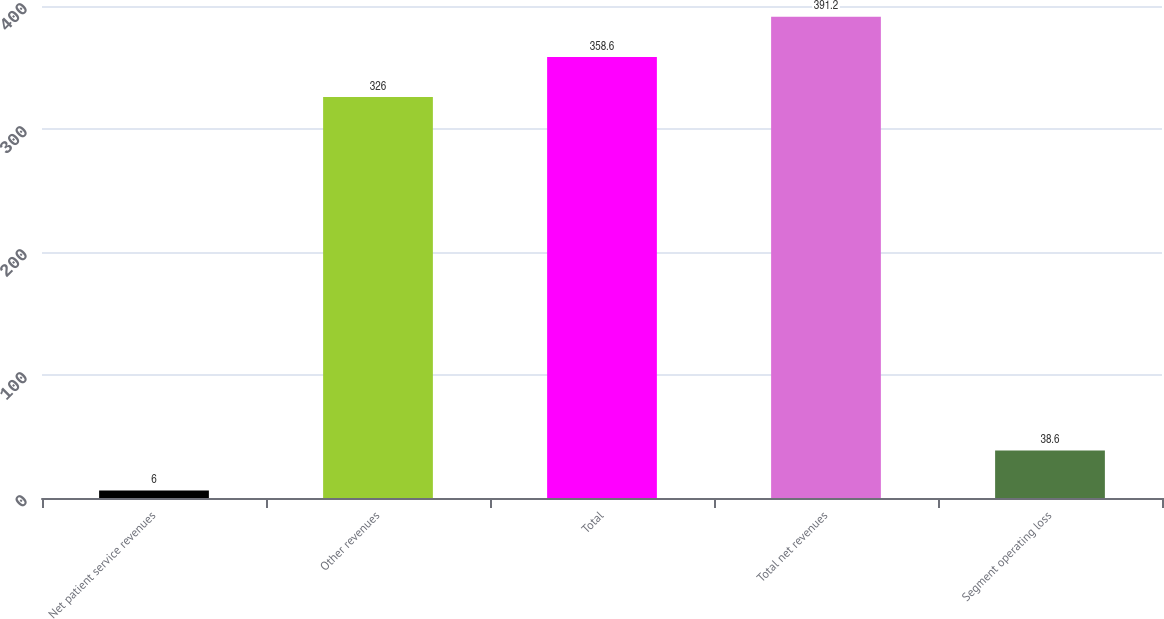Convert chart to OTSL. <chart><loc_0><loc_0><loc_500><loc_500><bar_chart><fcel>Net patient service revenues<fcel>Other revenues<fcel>Total<fcel>Total net revenues<fcel>Segment operating loss<nl><fcel>6<fcel>326<fcel>358.6<fcel>391.2<fcel>38.6<nl></chart> 